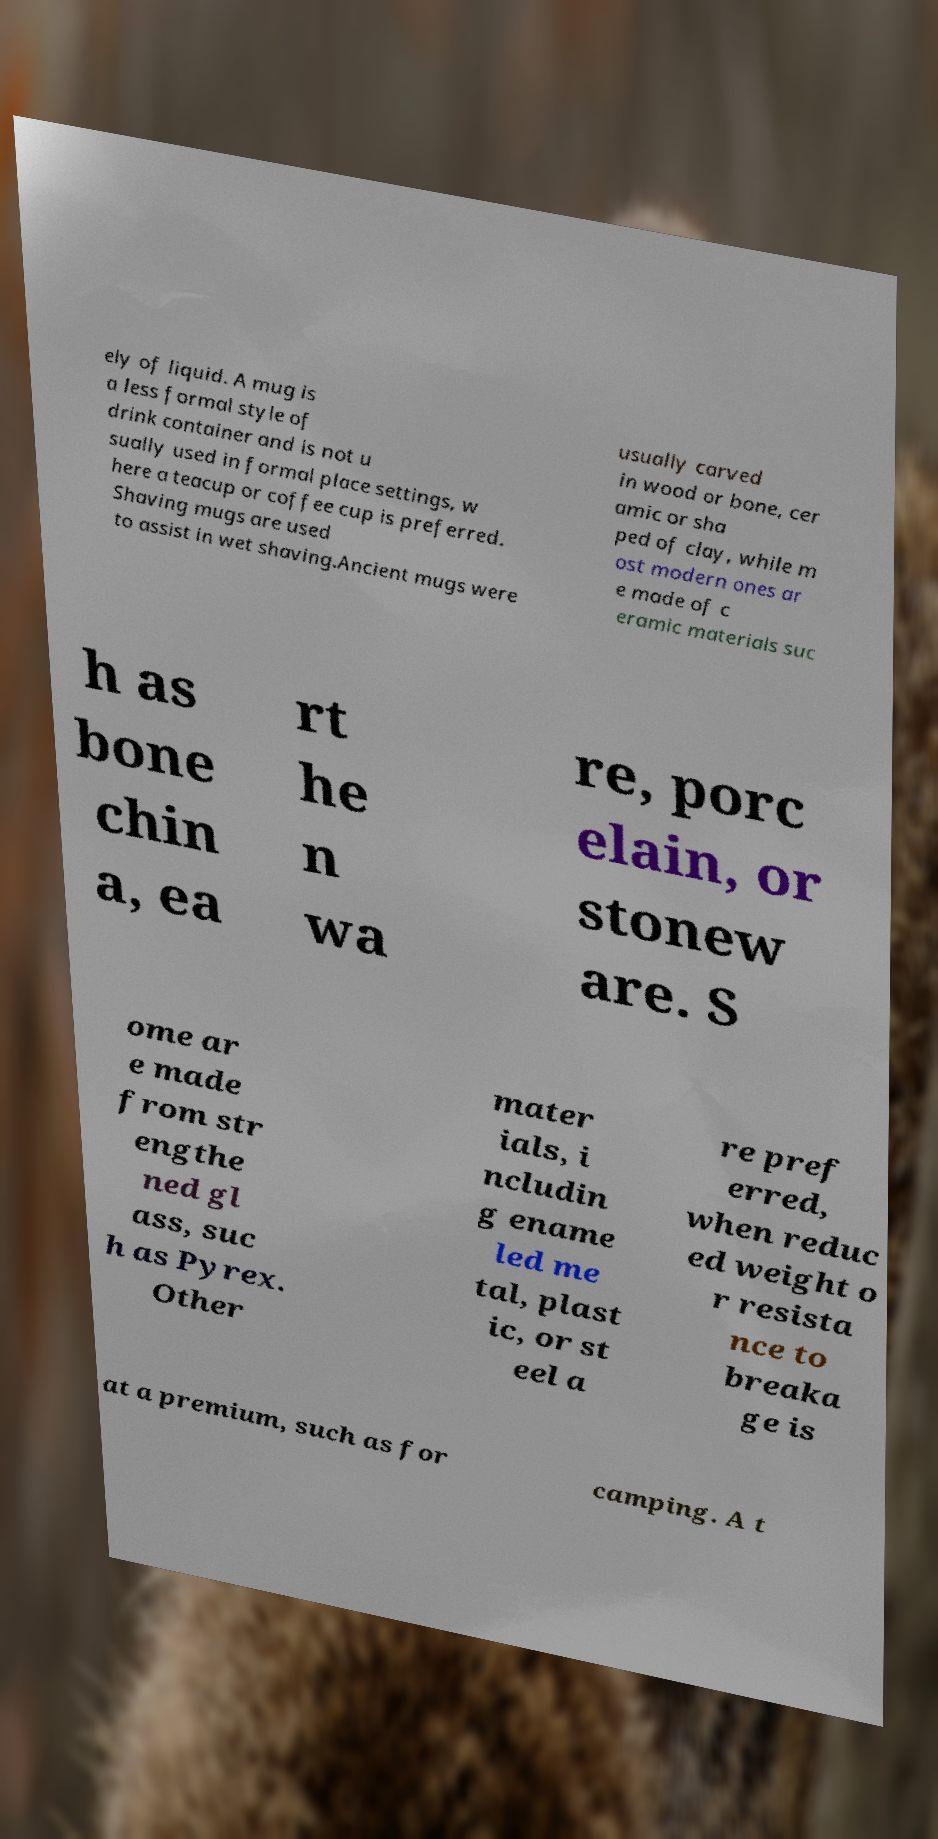Please read and relay the text visible in this image. What does it say? ely of liquid. A mug is a less formal style of drink container and is not u sually used in formal place settings, w here a teacup or coffee cup is preferred. Shaving mugs are used to assist in wet shaving.Ancient mugs were usually carved in wood or bone, cer amic or sha ped of clay, while m ost modern ones ar e made of c eramic materials suc h as bone chin a, ea rt he n wa re, porc elain, or stonew are. S ome ar e made from str engthe ned gl ass, suc h as Pyrex. Other mater ials, i ncludin g ename led me tal, plast ic, or st eel a re pref erred, when reduc ed weight o r resista nce to breaka ge is at a premium, such as for camping. A t 